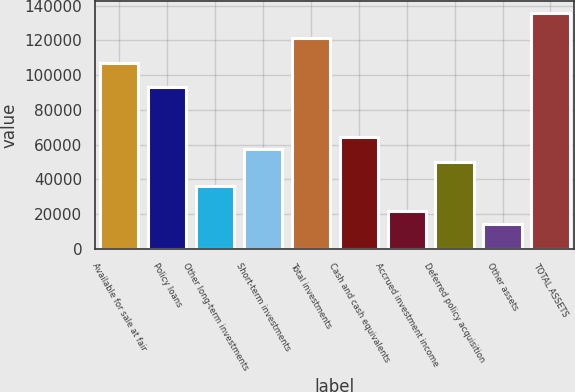<chart> <loc_0><loc_0><loc_500><loc_500><bar_chart><fcel>Available for sale at fair<fcel>Policy loans<fcel>Other long-term investments<fcel>Short-term investments<fcel>Total investments<fcel>Cash and cash equivalents<fcel>Accrued investment income<fcel>Deferred policy acquisition<fcel>Other assets<fcel>TOTAL ASSETS<nl><fcel>107296<fcel>93009.6<fcel>35864<fcel>57293.6<fcel>121582<fcel>64436.8<fcel>21577.6<fcel>50150.4<fcel>14434.4<fcel>135869<nl></chart> 